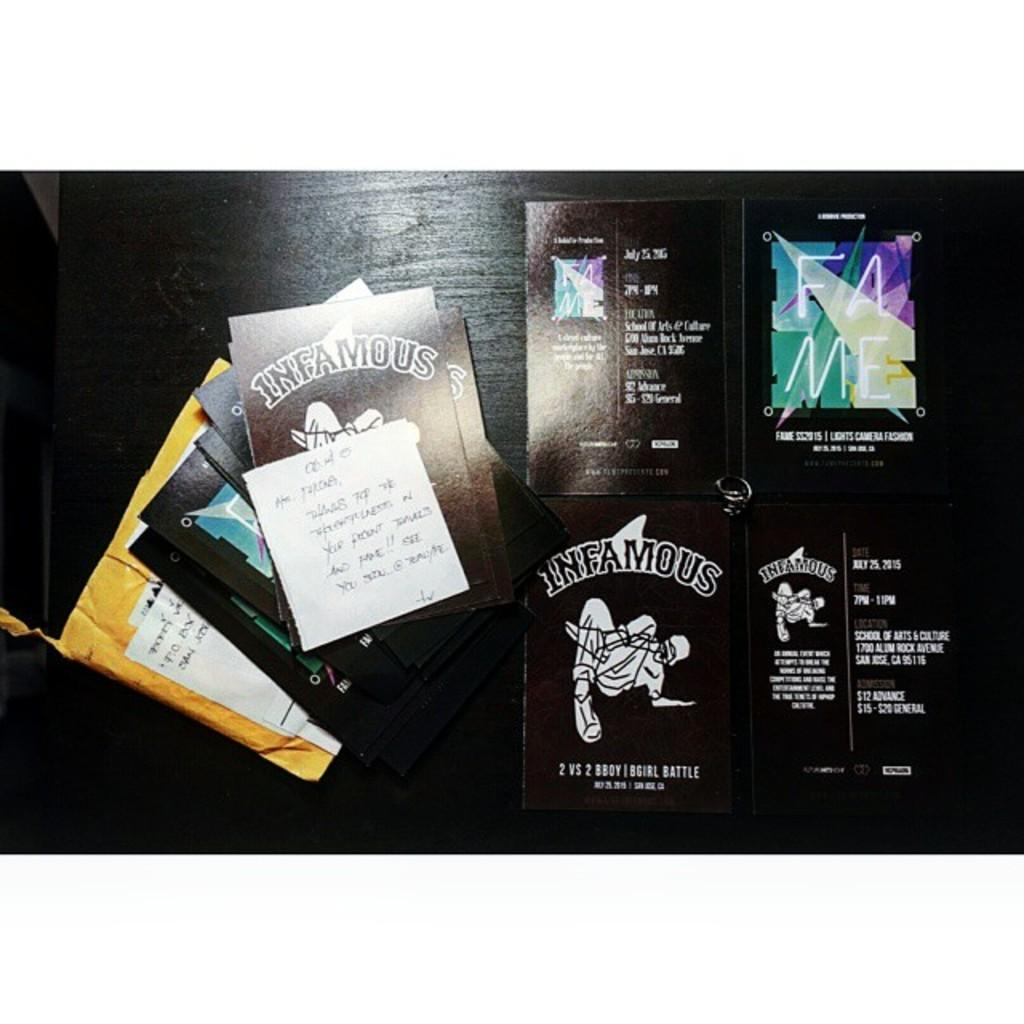<image>
Relay a brief, clear account of the picture shown. Black glossy paper that says Infamous on it. 